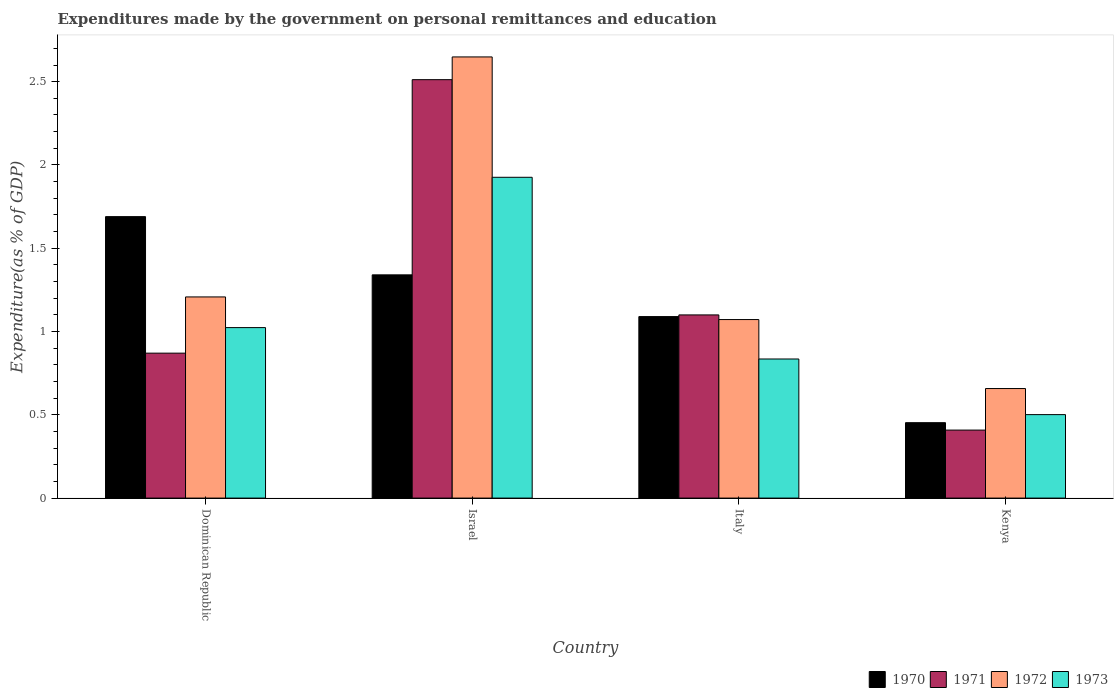How many different coloured bars are there?
Your answer should be very brief. 4. How many groups of bars are there?
Make the answer very short. 4. Are the number of bars per tick equal to the number of legend labels?
Your response must be concise. Yes. Are the number of bars on each tick of the X-axis equal?
Your answer should be compact. Yes. How many bars are there on the 2nd tick from the right?
Ensure brevity in your answer.  4. What is the label of the 4th group of bars from the left?
Your answer should be very brief. Kenya. What is the expenditures made by the government on personal remittances and education in 1970 in Italy?
Offer a terse response. 1.09. Across all countries, what is the maximum expenditures made by the government on personal remittances and education in 1971?
Provide a short and direct response. 2.51. Across all countries, what is the minimum expenditures made by the government on personal remittances and education in 1971?
Offer a very short reply. 0.41. In which country was the expenditures made by the government on personal remittances and education in 1970 maximum?
Make the answer very short. Dominican Republic. In which country was the expenditures made by the government on personal remittances and education in 1973 minimum?
Offer a terse response. Kenya. What is the total expenditures made by the government on personal remittances and education in 1971 in the graph?
Provide a short and direct response. 4.89. What is the difference between the expenditures made by the government on personal remittances and education in 1970 in Italy and that in Kenya?
Your answer should be very brief. 0.64. What is the difference between the expenditures made by the government on personal remittances and education in 1970 in Kenya and the expenditures made by the government on personal remittances and education in 1973 in Dominican Republic?
Make the answer very short. -0.57. What is the average expenditures made by the government on personal remittances and education in 1973 per country?
Give a very brief answer. 1.07. What is the difference between the expenditures made by the government on personal remittances and education of/in 1970 and expenditures made by the government on personal remittances and education of/in 1971 in Israel?
Give a very brief answer. -1.17. What is the ratio of the expenditures made by the government on personal remittances and education in 1972 in Dominican Republic to that in Israel?
Offer a terse response. 0.46. Is the expenditures made by the government on personal remittances and education in 1971 in Israel less than that in Kenya?
Ensure brevity in your answer.  No. What is the difference between the highest and the second highest expenditures made by the government on personal remittances and education in 1971?
Offer a very short reply. -0.23. What is the difference between the highest and the lowest expenditures made by the government on personal remittances and education in 1970?
Offer a very short reply. 1.24. What does the 1st bar from the left in Italy represents?
Give a very brief answer. 1970. What does the 4th bar from the right in Kenya represents?
Give a very brief answer. 1970. Is it the case that in every country, the sum of the expenditures made by the government on personal remittances and education in 1970 and expenditures made by the government on personal remittances and education in 1973 is greater than the expenditures made by the government on personal remittances and education in 1972?
Offer a very short reply. Yes. Are all the bars in the graph horizontal?
Your answer should be very brief. No. Are the values on the major ticks of Y-axis written in scientific E-notation?
Offer a terse response. No. Does the graph contain any zero values?
Provide a short and direct response. No. Does the graph contain grids?
Your answer should be very brief. No. Where does the legend appear in the graph?
Ensure brevity in your answer.  Bottom right. How many legend labels are there?
Give a very brief answer. 4. How are the legend labels stacked?
Give a very brief answer. Horizontal. What is the title of the graph?
Your response must be concise. Expenditures made by the government on personal remittances and education. Does "1969" appear as one of the legend labels in the graph?
Ensure brevity in your answer.  No. What is the label or title of the X-axis?
Give a very brief answer. Country. What is the label or title of the Y-axis?
Provide a short and direct response. Expenditure(as % of GDP). What is the Expenditure(as % of GDP) of 1970 in Dominican Republic?
Keep it short and to the point. 1.69. What is the Expenditure(as % of GDP) in 1971 in Dominican Republic?
Keep it short and to the point. 0.87. What is the Expenditure(as % of GDP) of 1972 in Dominican Republic?
Your answer should be compact. 1.21. What is the Expenditure(as % of GDP) in 1973 in Dominican Republic?
Your answer should be compact. 1.02. What is the Expenditure(as % of GDP) of 1970 in Israel?
Provide a succinct answer. 1.34. What is the Expenditure(as % of GDP) in 1971 in Israel?
Give a very brief answer. 2.51. What is the Expenditure(as % of GDP) of 1972 in Israel?
Your answer should be very brief. 2.65. What is the Expenditure(as % of GDP) in 1973 in Israel?
Provide a short and direct response. 1.93. What is the Expenditure(as % of GDP) in 1970 in Italy?
Ensure brevity in your answer.  1.09. What is the Expenditure(as % of GDP) of 1971 in Italy?
Your answer should be compact. 1.1. What is the Expenditure(as % of GDP) in 1972 in Italy?
Your response must be concise. 1.07. What is the Expenditure(as % of GDP) of 1973 in Italy?
Offer a terse response. 0.84. What is the Expenditure(as % of GDP) in 1970 in Kenya?
Give a very brief answer. 0.45. What is the Expenditure(as % of GDP) in 1971 in Kenya?
Offer a terse response. 0.41. What is the Expenditure(as % of GDP) of 1972 in Kenya?
Give a very brief answer. 0.66. What is the Expenditure(as % of GDP) of 1973 in Kenya?
Give a very brief answer. 0.5. Across all countries, what is the maximum Expenditure(as % of GDP) in 1970?
Ensure brevity in your answer.  1.69. Across all countries, what is the maximum Expenditure(as % of GDP) of 1971?
Keep it short and to the point. 2.51. Across all countries, what is the maximum Expenditure(as % of GDP) in 1972?
Make the answer very short. 2.65. Across all countries, what is the maximum Expenditure(as % of GDP) in 1973?
Provide a short and direct response. 1.93. Across all countries, what is the minimum Expenditure(as % of GDP) of 1970?
Your answer should be compact. 0.45. Across all countries, what is the minimum Expenditure(as % of GDP) in 1971?
Offer a very short reply. 0.41. Across all countries, what is the minimum Expenditure(as % of GDP) in 1972?
Ensure brevity in your answer.  0.66. Across all countries, what is the minimum Expenditure(as % of GDP) in 1973?
Offer a terse response. 0.5. What is the total Expenditure(as % of GDP) in 1970 in the graph?
Your answer should be compact. 4.57. What is the total Expenditure(as % of GDP) in 1971 in the graph?
Your response must be concise. 4.89. What is the total Expenditure(as % of GDP) of 1972 in the graph?
Give a very brief answer. 5.59. What is the total Expenditure(as % of GDP) in 1973 in the graph?
Keep it short and to the point. 4.29. What is the difference between the Expenditure(as % of GDP) in 1970 in Dominican Republic and that in Israel?
Offer a very short reply. 0.35. What is the difference between the Expenditure(as % of GDP) in 1971 in Dominican Republic and that in Israel?
Provide a short and direct response. -1.64. What is the difference between the Expenditure(as % of GDP) in 1972 in Dominican Republic and that in Israel?
Your response must be concise. -1.44. What is the difference between the Expenditure(as % of GDP) of 1973 in Dominican Republic and that in Israel?
Offer a very short reply. -0.9. What is the difference between the Expenditure(as % of GDP) in 1970 in Dominican Republic and that in Italy?
Provide a short and direct response. 0.6. What is the difference between the Expenditure(as % of GDP) in 1971 in Dominican Republic and that in Italy?
Offer a very short reply. -0.23. What is the difference between the Expenditure(as % of GDP) in 1972 in Dominican Republic and that in Italy?
Provide a succinct answer. 0.14. What is the difference between the Expenditure(as % of GDP) in 1973 in Dominican Republic and that in Italy?
Keep it short and to the point. 0.19. What is the difference between the Expenditure(as % of GDP) of 1970 in Dominican Republic and that in Kenya?
Make the answer very short. 1.24. What is the difference between the Expenditure(as % of GDP) of 1971 in Dominican Republic and that in Kenya?
Provide a succinct answer. 0.46. What is the difference between the Expenditure(as % of GDP) in 1972 in Dominican Republic and that in Kenya?
Provide a short and direct response. 0.55. What is the difference between the Expenditure(as % of GDP) of 1973 in Dominican Republic and that in Kenya?
Your answer should be very brief. 0.52. What is the difference between the Expenditure(as % of GDP) in 1970 in Israel and that in Italy?
Keep it short and to the point. 0.25. What is the difference between the Expenditure(as % of GDP) in 1971 in Israel and that in Italy?
Offer a terse response. 1.41. What is the difference between the Expenditure(as % of GDP) of 1972 in Israel and that in Italy?
Your response must be concise. 1.58. What is the difference between the Expenditure(as % of GDP) of 1970 in Israel and that in Kenya?
Your response must be concise. 0.89. What is the difference between the Expenditure(as % of GDP) of 1971 in Israel and that in Kenya?
Provide a short and direct response. 2.1. What is the difference between the Expenditure(as % of GDP) in 1972 in Israel and that in Kenya?
Your response must be concise. 1.99. What is the difference between the Expenditure(as % of GDP) in 1973 in Israel and that in Kenya?
Your answer should be compact. 1.42. What is the difference between the Expenditure(as % of GDP) of 1970 in Italy and that in Kenya?
Provide a succinct answer. 0.64. What is the difference between the Expenditure(as % of GDP) in 1971 in Italy and that in Kenya?
Provide a succinct answer. 0.69. What is the difference between the Expenditure(as % of GDP) of 1972 in Italy and that in Kenya?
Offer a very short reply. 0.41. What is the difference between the Expenditure(as % of GDP) of 1973 in Italy and that in Kenya?
Keep it short and to the point. 0.33. What is the difference between the Expenditure(as % of GDP) in 1970 in Dominican Republic and the Expenditure(as % of GDP) in 1971 in Israel?
Your response must be concise. -0.82. What is the difference between the Expenditure(as % of GDP) in 1970 in Dominican Republic and the Expenditure(as % of GDP) in 1972 in Israel?
Your response must be concise. -0.96. What is the difference between the Expenditure(as % of GDP) of 1970 in Dominican Republic and the Expenditure(as % of GDP) of 1973 in Israel?
Ensure brevity in your answer.  -0.24. What is the difference between the Expenditure(as % of GDP) in 1971 in Dominican Republic and the Expenditure(as % of GDP) in 1972 in Israel?
Ensure brevity in your answer.  -1.78. What is the difference between the Expenditure(as % of GDP) in 1971 in Dominican Republic and the Expenditure(as % of GDP) in 1973 in Israel?
Provide a succinct answer. -1.06. What is the difference between the Expenditure(as % of GDP) in 1972 in Dominican Republic and the Expenditure(as % of GDP) in 1973 in Israel?
Provide a short and direct response. -0.72. What is the difference between the Expenditure(as % of GDP) in 1970 in Dominican Republic and the Expenditure(as % of GDP) in 1971 in Italy?
Your answer should be compact. 0.59. What is the difference between the Expenditure(as % of GDP) in 1970 in Dominican Republic and the Expenditure(as % of GDP) in 1972 in Italy?
Offer a very short reply. 0.62. What is the difference between the Expenditure(as % of GDP) in 1970 in Dominican Republic and the Expenditure(as % of GDP) in 1973 in Italy?
Give a very brief answer. 0.85. What is the difference between the Expenditure(as % of GDP) in 1971 in Dominican Republic and the Expenditure(as % of GDP) in 1972 in Italy?
Make the answer very short. -0.2. What is the difference between the Expenditure(as % of GDP) in 1971 in Dominican Republic and the Expenditure(as % of GDP) in 1973 in Italy?
Give a very brief answer. 0.04. What is the difference between the Expenditure(as % of GDP) in 1972 in Dominican Republic and the Expenditure(as % of GDP) in 1973 in Italy?
Offer a very short reply. 0.37. What is the difference between the Expenditure(as % of GDP) of 1970 in Dominican Republic and the Expenditure(as % of GDP) of 1971 in Kenya?
Provide a succinct answer. 1.28. What is the difference between the Expenditure(as % of GDP) in 1970 in Dominican Republic and the Expenditure(as % of GDP) in 1972 in Kenya?
Your response must be concise. 1.03. What is the difference between the Expenditure(as % of GDP) of 1970 in Dominican Republic and the Expenditure(as % of GDP) of 1973 in Kenya?
Offer a terse response. 1.19. What is the difference between the Expenditure(as % of GDP) of 1971 in Dominican Republic and the Expenditure(as % of GDP) of 1972 in Kenya?
Your response must be concise. 0.21. What is the difference between the Expenditure(as % of GDP) of 1971 in Dominican Republic and the Expenditure(as % of GDP) of 1973 in Kenya?
Provide a short and direct response. 0.37. What is the difference between the Expenditure(as % of GDP) of 1972 in Dominican Republic and the Expenditure(as % of GDP) of 1973 in Kenya?
Provide a short and direct response. 0.71. What is the difference between the Expenditure(as % of GDP) of 1970 in Israel and the Expenditure(as % of GDP) of 1971 in Italy?
Provide a short and direct response. 0.24. What is the difference between the Expenditure(as % of GDP) of 1970 in Israel and the Expenditure(as % of GDP) of 1972 in Italy?
Make the answer very short. 0.27. What is the difference between the Expenditure(as % of GDP) of 1970 in Israel and the Expenditure(as % of GDP) of 1973 in Italy?
Provide a short and direct response. 0.51. What is the difference between the Expenditure(as % of GDP) of 1971 in Israel and the Expenditure(as % of GDP) of 1972 in Italy?
Keep it short and to the point. 1.44. What is the difference between the Expenditure(as % of GDP) in 1971 in Israel and the Expenditure(as % of GDP) in 1973 in Italy?
Ensure brevity in your answer.  1.68. What is the difference between the Expenditure(as % of GDP) in 1972 in Israel and the Expenditure(as % of GDP) in 1973 in Italy?
Provide a succinct answer. 1.81. What is the difference between the Expenditure(as % of GDP) in 1970 in Israel and the Expenditure(as % of GDP) in 1971 in Kenya?
Keep it short and to the point. 0.93. What is the difference between the Expenditure(as % of GDP) in 1970 in Israel and the Expenditure(as % of GDP) in 1972 in Kenya?
Give a very brief answer. 0.68. What is the difference between the Expenditure(as % of GDP) in 1970 in Israel and the Expenditure(as % of GDP) in 1973 in Kenya?
Give a very brief answer. 0.84. What is the difference between the Expenditure(as % of GDP) of 1971 in Israel and the Expenditure(as % of GDP) of 1972 in Kenya?
Provide a succinct answer. 1.85. What is the difference between the Expenditure(as % of GDP) in 1971 in Israel and the Expenditure(as % of GDP) in 1973 in Kenya?
Offer a terse response. 2.01. What is the difference between the Expenditure(as % of GDP) of 1972 in Israel and the Expenditure(as % of GDP) of 1973 in Kenya?
Your answer should be compact. 2.15. What is the difference between the Expenditure(as % of GDP) of 1970 in Italy and the Expenditure(as % of GDP) of 1971 in Kenya?
Ensure brevity in your answer.  0.68. What is the difference between the Expenditure(as % of GDP) of 1970 in Italy and the Expenditure(as % of GDP) of 1972 in Kenya?
Provide a short and direct response. 0.43. What is the difference between the Expenditure(as % of GDP) of 1970 in Italy and the Expenditure(as % of GDP) of 1973 in Kenya?
Your answer should be very brief. 0.59. What is the difference between the Expenditure(as % of GDP) of 1971 in Italy and the Expenditure(as % of GDP) of 1972 in Kenya?
Offer a very short reply. 0.44. What is the difference between the Expenditure(as % of GDP) of 1971 in Italy and the Expenditure(as % of GDP) of 1973 in Kenya?
Keep it short and to the point. 0.6. What is the difference between the Expenditure(as % of GDP) of 1972 in Italy and the Expenditure(as % of GDP) of 1973 in Kenya?
Make the answer very short. 0.57. What is the average Expenditure(as % of GDP) of 1970 per country?
Ensure brevity in your answer.  1.14. What is the average Expenditure(as % of GDP) of 1971 per country?
Give a very brief answer. 1.22. What is the average Expenditure(as % of GDP) of 1972 per country?
Your answer should be very brief. 1.4. What is the average Expenditure(as % of GDP) of 1973 per country?
Provide a short and direct response. 1.07. What is the difference between the Expenditure(as % of GDP) of 1970 and Expenditure(as % of GDP) of 1971 in Dominican Republic?
Your answer should be compact. 0.82. What is the difference between the Expenditure(as % of GDP) of 1970 and Expenditure(as % of GDP) of 1972 in Dominican Republic?
Your answer should be very brief. 0.48. What is the difference between the Expenditure(as % of GDP) in 1970 and Expenditure(as % of GDP) in 1973 in Dominican Republic?
Provide a short and direct response. 0.67. What is the difference between the Expenditure(as % of GDP) of 1971 and Expenditure(as % of GDP) of 1972 in Dominican Republic?
Ensure brevity in your answer.  -0.34. What is the difference between the Expenditure(as % of GDP) in 1971 and Expenditure(as % of GDP) in 1973 in Dominican Republic?
Offer a very short reply. -0.15. What is the difference between the Expenditure(as % of GDP) of 1972 and Expenditure(as % of GDP) of 1973 in Dominican Republic?
Your response must be concise. 0.18. What is the difference between the Expenditure(as % of GDP) of 1970 and Expenditure(as % of GDP) of 1971 in Israel?
Ensure brevity in your answer.  -1.17. What is the difference between the Expenditure(as % of GDP) of 1970 and Expenditure(as % of GDP) of 1972 in Israel?
Your response must be concise. -1.31. What is the difference between the Expenditure(as % of GDP) of 1970 and Expenditure(as % of GDP) of 1973 in Israel?
Your response must be concise. -0.59. What is the difference between the Expenditure(as % of GDP) of 1971 and Expenditure(as % of GDP) of 1972 in Israel?
Your answer should be compact. -0.14. What is the difference between the Expenditure(as % of GDP) of 1971 and Expenditure(as % of GDP) of 1973 in Israel?
Keep it short and to the point. 0.59. What is the difference between the Expenditure(as % of GDP) in 1972 and Expenditure(as % of GDP) in 1973 in Israel?
Your answer should be very brief. 0.72. What is the difference between the Expenditure(as % of GDP) in 1970 and Expenditure(as % of GDP) in 1971 in Italy?
Your response must be concise. -0.01. What is the difference between the Expenditure(as % of GDP) of 1970 and Expenditure(as % of GDP) of 1972 in Italy?
Offer a terse response. 0.02. What is the difference between the Expenditure(as % of GDP) of 1970 and Expenditure(as % of GDP) of 1973 in Italy?
Offer a very short reply. 0.25. What is the difference between the Expenditure(as % of GDP) in 1971 and Expenditure(as % of GDP) in 1972 in Italy?
Provide a succinct answer. 0.03. What is the difference between the Expenditure(as % of GDP) in 1971 and Expenditure(as % of GDP) in 1973 in Italy?
Provide a short and direct response. 0.26. What is the difference between the Expenditure(as % of GDP) in 1972 and Expenditure(as % of GDP) in 1973 in Italy?
Make the answer very short. 0.24. What is the difference between the Expenditure(as % of GDP) in 1970 and Expenditure(as % of GDP) in 1971 in Kenya?
Provide a succinct answer. 0.04. What is the difference between the Expenditure(as % of GDP) of 1970 and Expenditure(as % of GDP) of 1972 in Kenya?
Keep it short and to the point. -0.2. What is the difference between the Expenditure(as % of GDP) of 1970 and Expenditure(as % of GDP) of 1973 in Kenya?
Your answer should be compact. -0.05. What is the difference between the Expenditure(as % of GDP) of 1971 and Expenditure(as % of GDP) of 1972 in Kenya?
Your response must be concise. -0.25. What is the difference between the Expenditure(as % of GDP) in 1971 and Expenditure(as % of GDP) in 1973 in Kenya?
Make the answer very short. -0.09. What is the difference between the Expenditure(as % of GDP) of 1972 and Expenditure(as % of GDP) of 1973 in Kenya?
Give a very brief answer. 0.16. What is the ratio of the Expenditure(as % of GDP) in 1970 in Dominican Republic to that in Israel?
Keep it short and to the point. 1.26. What is the ratio of the Expenditure(as % of GDP) of 1971 in Dominican Republic to that in Israel?
Your answer should be very brief. 0.35. What is the ratio of the Expenditure(as % of GDP) of 1972 in Dominican Republic to that in Israel?
Keep it short and to the point. 0.46. What is the ratio of the Expenditure(as % of GDP) in 1973 in Dominican Republic to that in Israel?
Your response must be concise. 0.53. What is the ratio of the Expenditure(as % of GDP) of 1970 in Dominican Republic to that in Italy?
Keep it short and to the point. 1.55. What is the ratio of the Expenditure(as % of GDP) in 1971 in Dominican Republic to that in Italy?
Make the answer very short. 0.79. What is the ratio of the Expenditure(as % of GDP) in 1972 in Dominican Republic to that in Italy?
Provide a succinct answer. 1.13. What is the ratio of the Expenditure(as % of GDP) in 1973 in Dominican Republic to that in Italy?
Make the answer very short. 1.23. What is the ratio of the Expenditure(as % of GDP) of 1970 in Dominican Republic to that in Kenya?
Your answer should be compact. 3.73. What is the ratio of the Expenditure(as % of GDP) in 1971 in Dominican Republic to that in Kenya?
Provide a short and direct response. 2.13. What is the ratio of the Expenditure(as % of GDP) of 1972 in Dominican Republic to that in Kenya?
Offer a very short reply. 1.84. What is the ratio of the Expenditure(as % of GDP) in 1973 in Dominican Republic to that in Kenya?
Give a very brief answer. 2.04. What is the ratio of the Expenditure(as % of GDP) of 1970 in Israel to that in Italy?
Offer a very short reply. 1.23. What is the ratio of the Expenditure(as % of GDP) in 1971 in Israel to that in Italy?
Your answer should be compact. 2.28. What is the ratio of the Expenditure(as % of GDP) in 1972 in Israel to that in Italy?
Your response must be concise. 2.47. What is the ratio of the Expenditure(as % of GDP) of 1973 in Israel to that in Italy?
Your answer should be compact. 2.31. What is the ratio of the Expenditure(as % of GDP) of 1970 in Israel to that in Kenya?
Make the answer very short. 2.96. What is the ratio of the Expenditure(as % of GDP) of 1971 in Israel to that in Kenya?
Provide a succinct answer. 6.15. What is the ratio of the Expenditure(as % of GDP) in 1972 in Israel to that in Kenya?
Provide a succinct answer. 4.03. What is the ratio of the Expenditure(as % of GDP) in 1973 in Israel to that in Kenya?
Your response must be concise. 3.84. What is the ratio of the Expenditure(as % of GDP) in 1970 in Italy to that in Kenya?
Make the answer very short. 2.41. What is the ratio of the Expenditure(as % of GDP) in 1971 in Italy to that in Kenya?
Your answer should be compact. 2.69. What is the ratio of the Expenditure(as % of GDP) of 1972 in Italy to that in Kenya?
Keep it short and to the point. 1.63. What is the ratio of the Expenditure(as % of GDP) in 1973 in Italy to that in Kenya?
Offer a terse response. 1.67. What is the difference between the highest and the second highest Expenditure(as % of GDP) in 1970?
Make the answer very short. 0.35. What is the difference between the highest and the second highest Expenditure(as % of GDP) of 1971?
Ensure brevity in your answer.  1.41. What is the difference between the highest and the second highest Expenditure(as % of GDP) in 1972?
Offer a terse response. 1.44. What is the difference between the highest and the second highest Expenditure(as % of GDP) in 1973?
Provide a succinct answer. 0.9. What is the difference between the highest and the lowest Expenditure(as % of GDP) in 1970?
Keep it short and to the point. 1.24. What is the difference between the highest and the lowest Expenditure(as % of GDP) in 1971?
Provide a short and direct response. 2.1. What is the difference between the highest and the lowest Expenditure(as % of GDP) in 1972?
Ensure brevity in your answer.  1.99. What is the difference between the highest and the lowest Expenditure(as % of GDP) of 1973?
Offer a very short reply. 1.42. 